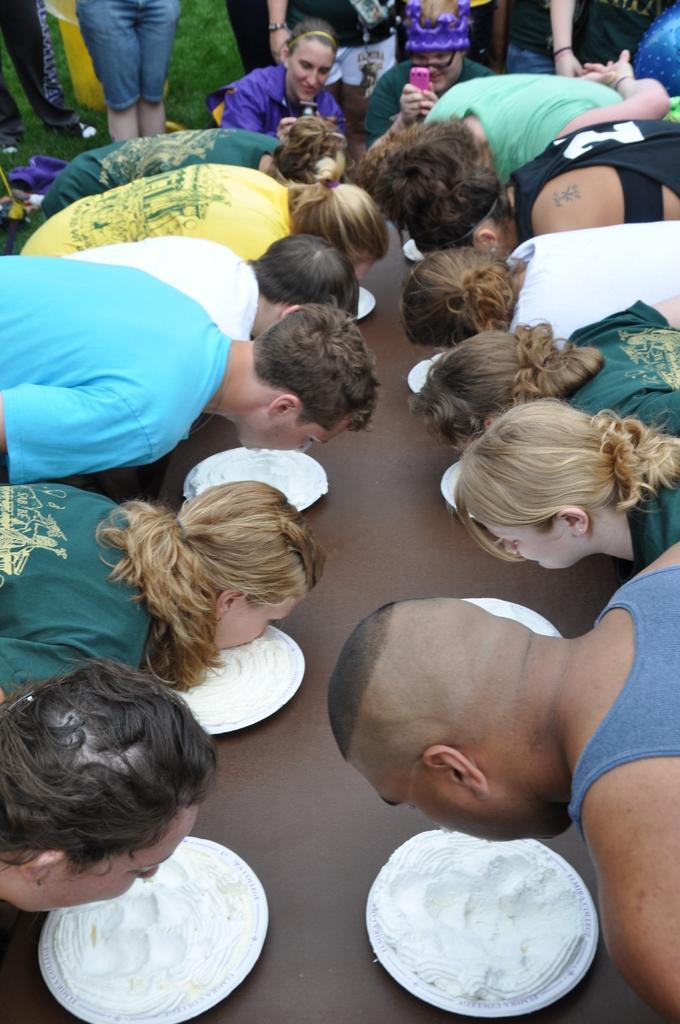In one or two sentences, can you explain what this image depicts? In the picture we can see a table on it, we can see some plates with a cream and people are looking deeply into that and in the background, we can see a person sitting and holding a mobile and capturing them and behind him we can see some people are standing. 